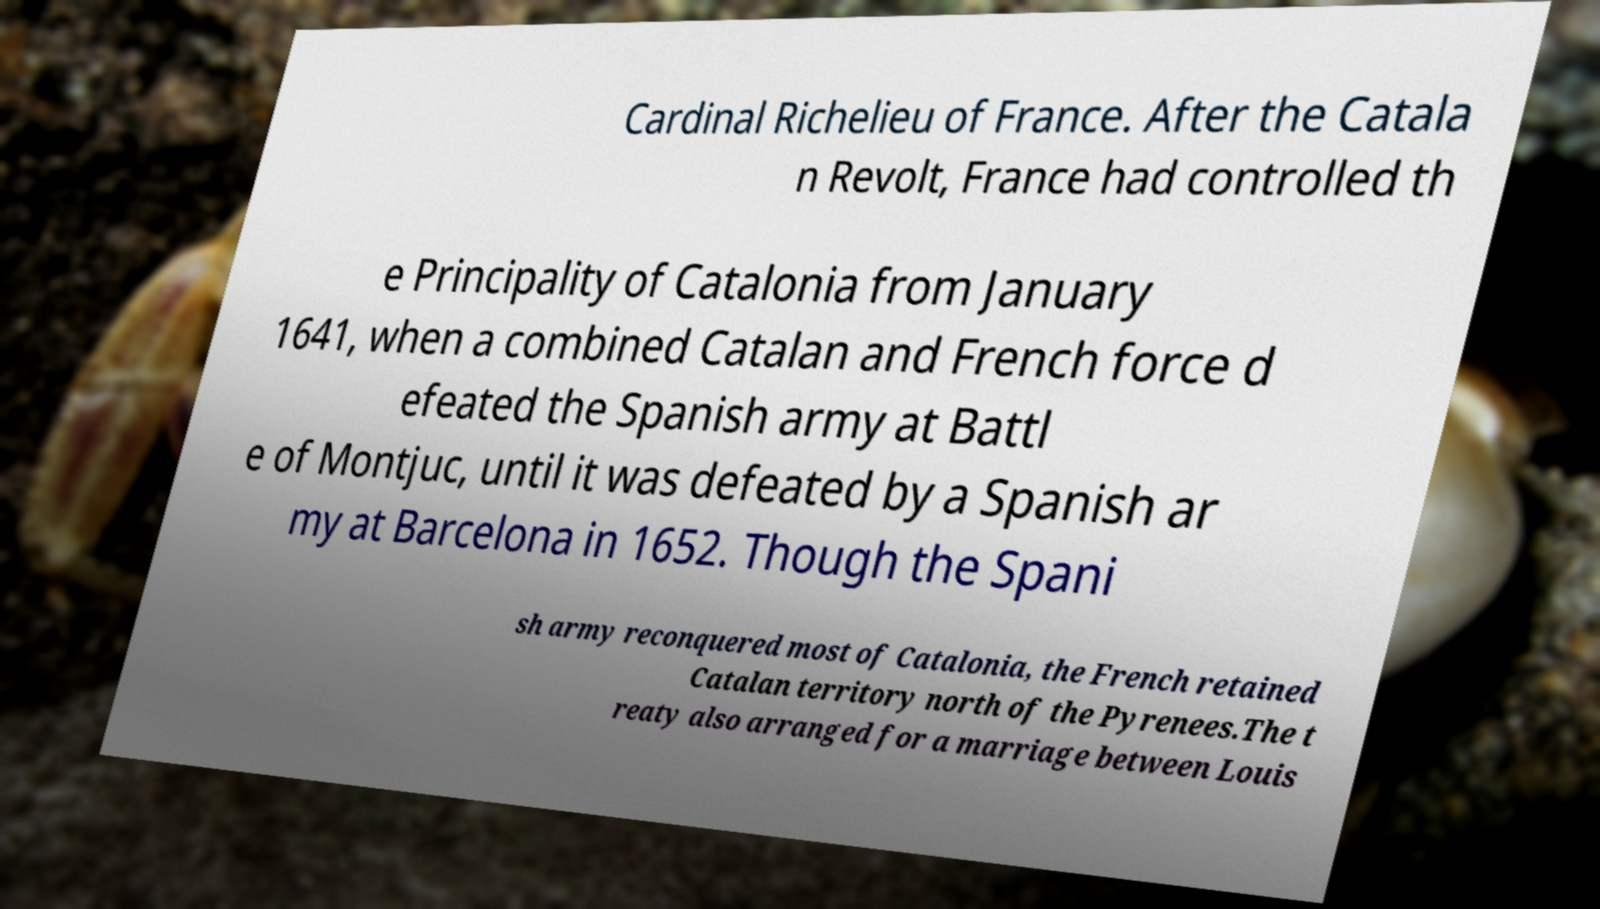Could you extract and type out the text from this image? Cardinal Richelieu of France. After the Catala n Revolt, France had controlled th e Principality of Catalonia from January 1641, when a combined Catalan and French force d efeated the Spanish army at Battl e of Montjuc, until it was defeated by a Spanish ar my at Barcelona in 1652. Though the Spani sh army reconquered most of Catalonia, the French retained Catalan territory north of the Pyrenees.The t reaty also arranged for a marriage between Louis 